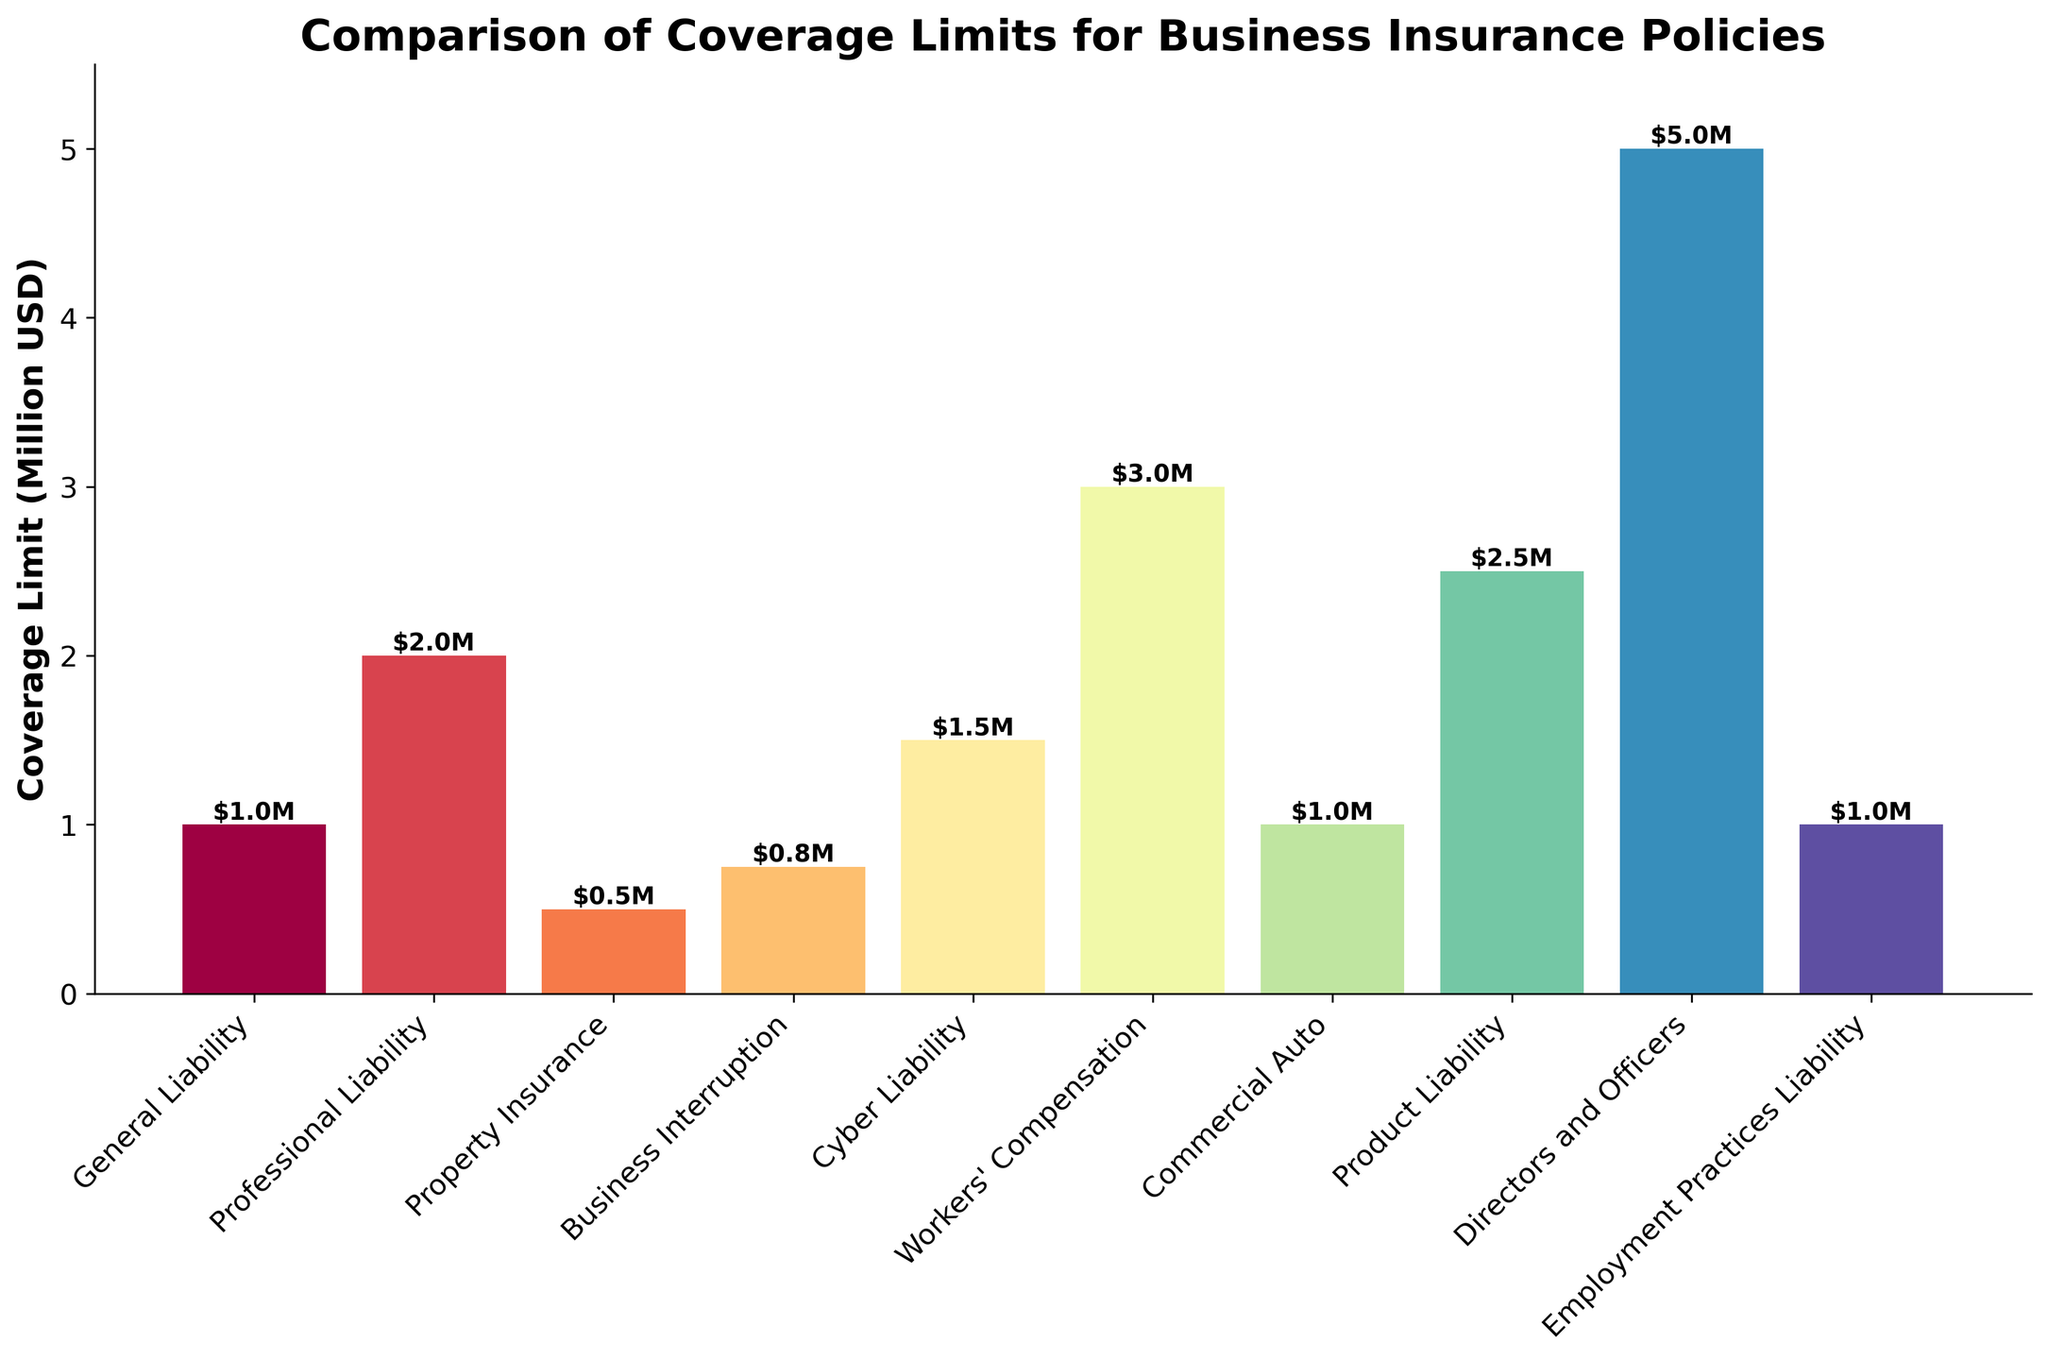What is the coverage limit for Cyber Liability insurance? The height of the Cyber Liability insurance bar represents its coverage limit. We see that it is labeled at $1.5M.
Answer: $1.5M Which insurance policy has the highest coverage limit? We compare the heights of all bars to identify the tallest one, which is Directors and Officers insurance, with a height of $5M.
Answer: Directors and Officers How much higher is the coverage limit for Directors and Officers insurance compared to Property Insurance? The coverage limit for Directors and Officers insurance is $5M, and for Property Insurance, it is $0.5M. The difference is calculated as $5M - $0.5M.
Answer: $4.5M What are the insurance policies with a coverage limit of $1M? We identify bars that are labeled with $1M. These include General Liability, Commercial Auto, and Employment Practices Liability.
Answer: General Liability, Commercial Auto, Employment Practices Liability Which policy has a higher coverage limit: Business Interruption or Cyber Liability? By comparing the heights of the bars for Business Interruption ($0.75M) and Cyber Liability ($1.5M), we see that Cyber Liability is higher.
Answer: Cyber Liability What is the total coverage limit for General Liability, Professional Liability, and Workers' Compensation insurance combined? Summing their respective coverage limits: General Liability ($1M) + Professional Liability ($2M) + Workers' Compensation ($3M).
Answer: $6M How does the coverage limit for Product Liability compare to Professional Liability? Product Liability insurance has a limit of $2.5M, while Professional Liability has $2M. Therefore, Product Liability is higher.
Answer: Product Liability Which insurance policy has the smallest coverage limit and what is it? We look for the shortest bar, which belongs to Property Insurance, with a limit of $0.5M.
Answer: Property Insurance, $0.5M What is the average coverage limit among all listed insurance policies? Summing all coverage limits and dividing by the number of policies: ($1M + $2M + $0.5M + $0.75M + $1.5M + $3M + $1M + $2.5M + $5M + $1M) / 10. This totals $18.25M, yielding an average of $18.25M / 10.
Answer: $1.825M How much more coverage does Directors and Officers insurance provide compared to the average coverage limit? Directors and Officers insurance has a limit of $5M. The average coverage limit is $1.825M. The difference is $5M - $1.825M.
Answer: $3.175M 